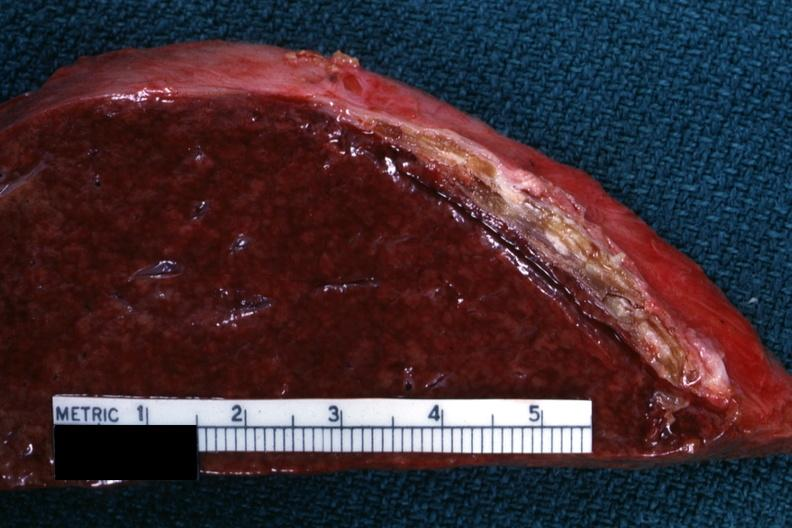s spleen present?
Answer the question using a single word or phrase. Yes 